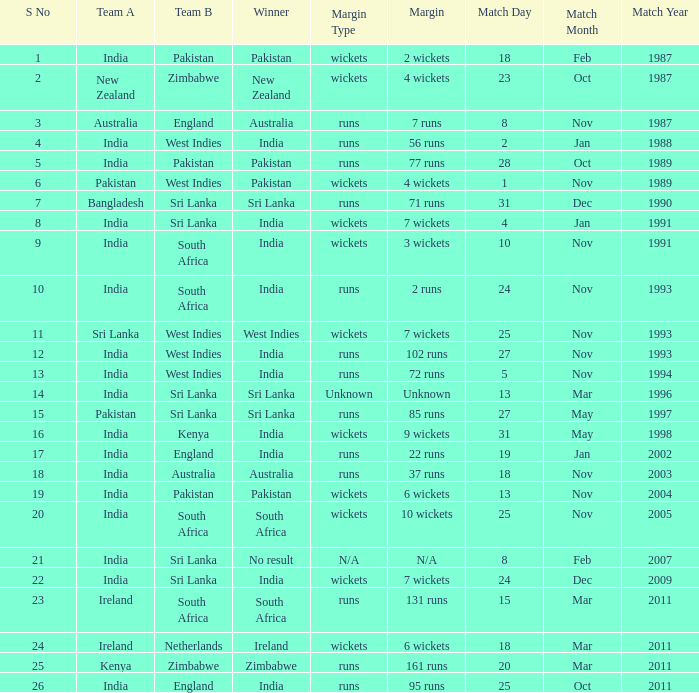How many games were won by a margin of 131 runs? 1.0. 